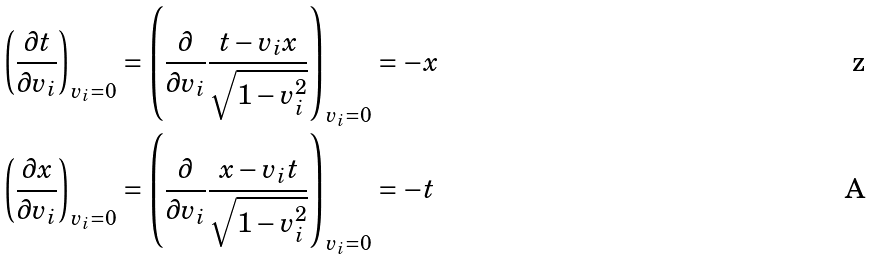Convert formula to latex. <formula><loc_0><loc_0><loc_500><loc_500>\left ( \frac { \partial t } { \partial v _ { i } } \right ) _ { v _ { i } = 0 } & = \left ( \frac { \partial } { \partial v _ { i } } \frac { t - v _ { i } x } { \sqrt { 1 - v _ { i } ^ { 2 } } } \right ) _ { v _ { i } = 0 } = - x \\ \left ( \frac { \partial x } { \partial v _ { i } } \right ) _ { v _ { i } = 0 } & = \left ( \frac { \partial } { \partial v _ { i } } \frac { x - v _ { i } t } { \sqrt { 1 - v _ { i } ^ { 2 } } } \right ) _ { v _ { i } = 0 } = - t</formula> 